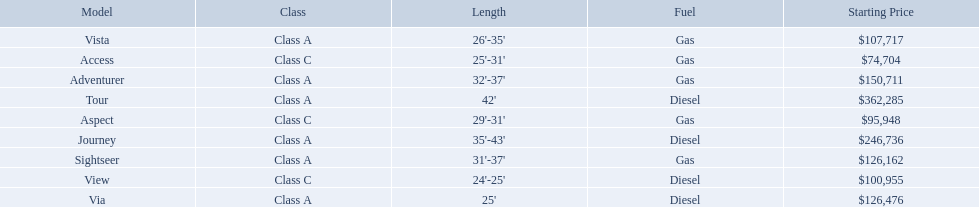What models are available from winnebago industries? Tour, Journey, Adventurer, Via, Sightseer, Vista, View, Aspect, Access. What are their starting prices? $362,285, $246,736, $150,711, $126,476, $126,162, $107,717, $100,955, $95,948, $74,704. Which model has the most costly starting price? Tour. Which models are manufactured by winnebago industries? Tour, Journey, Adventurer, Via, Sightseer, Vista, View, Aspect, Access. What type of fuel does each model require? Diesel, Diesel, Gas, Diesel, Gas, Gas, Diesel, Gas, Gas. And between the tour and aspect, which runs on diesel? Tour. 